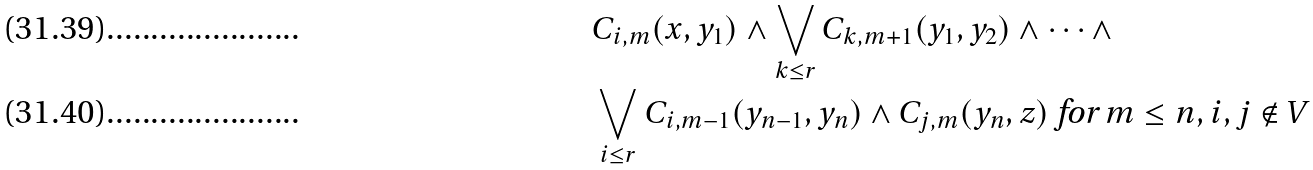Convert formula to latex. <formula><loc_0><loc_0><loc_500><loc_500>& C _ { i , m } ( x , y _ { 1 } ) \wedge \bigvee _ { k \leq r } C _ { k , m + 1 } ( y _ { 1 } , y _ { 2 } ) \wedge \dots \wedge \\ & \bigvee _ { i \leq r } C _ { i , m - 1 } ( y _ { n - 1 } , y _ { n } ) \wedge C _ { j , m } ( y _ { n } , z ) \text { for $m \leq n, i,j \not \in V$}</formula> 